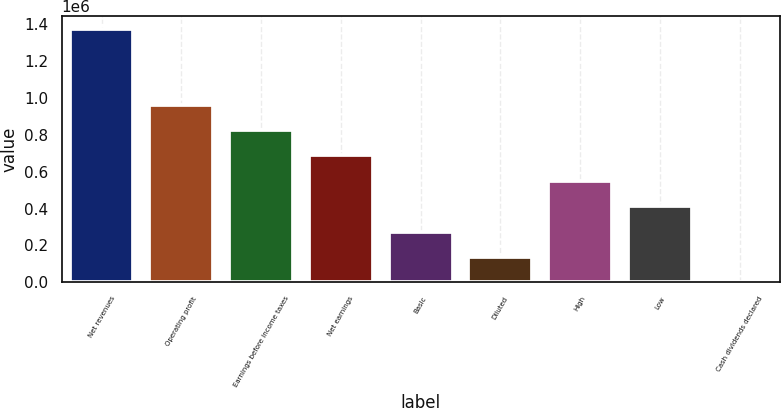Convert chart to OTSL. <chart><loc_0><loc_0><loc_500><loc_500><bar_chart><fcel>Net revenues<fcel>Operating profit<fcel>Earnings before income taxes<fcel>Net earnings<fcel>Basic<fcel>Diluted<fcel>High<fcel>Low<fcel>Cash dividends declared<nl><fcel>1.37518e+06<fcel>962629<fcel>825110<fcel>687592<fcel>275037<fcel>137519<fcel>550074<fcel>412555<fcel>0.2<nl></chart> 